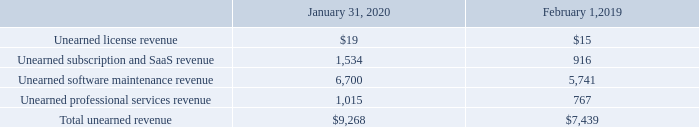Unearned Revenue
Unearned revenue as of the periods presented consisted of the following (table in millions):
Unearned subscription and SaaS revenue is generally recognized over time as customers consume the services or ratably over the term of the subscription, commencing upon provisioning of the service. Previously, unearned subscription and SaaS revenue was allocated between unearned license revenue and unearned software maintenance revenue in prior periods and has been reclassified to conform with current period presentation.
Unearned software maintenance revenue is attributable to our maintenance contracts and is generally recognized over time on a ratable basis over the contract duration. The weighted-average remaining contractual term as of January 31, 2020 was approximately two years. Unearned professional services revenue results primarily from prepaid professional services and is generally recognized as the services are performed.
What was unearned software maintenance revenue attributable to? Maintenance contracts and is generally recognized over time on a ratable basis over the contract duration. What was unearned professional services revenue a result of? Prepaid professional services and is generally recognized as the services are performed. Which years does the table provide information for unearned revenue? 2020, 2019. What was the change in Unearned subscription and SaaS revenue between 2019 and 2020?
Answer scale should be: million. 1,534-916
Answer: 618. How many years did Unearned software maintenance revenue exceed $5,000 million? 2020##2019
Answer: 2. What was the percentage change in total unearned revenue between 2019 and 2020?
Answer scale should be: percent. (9,268-7,439)/7,439
Answer: 24.59. 